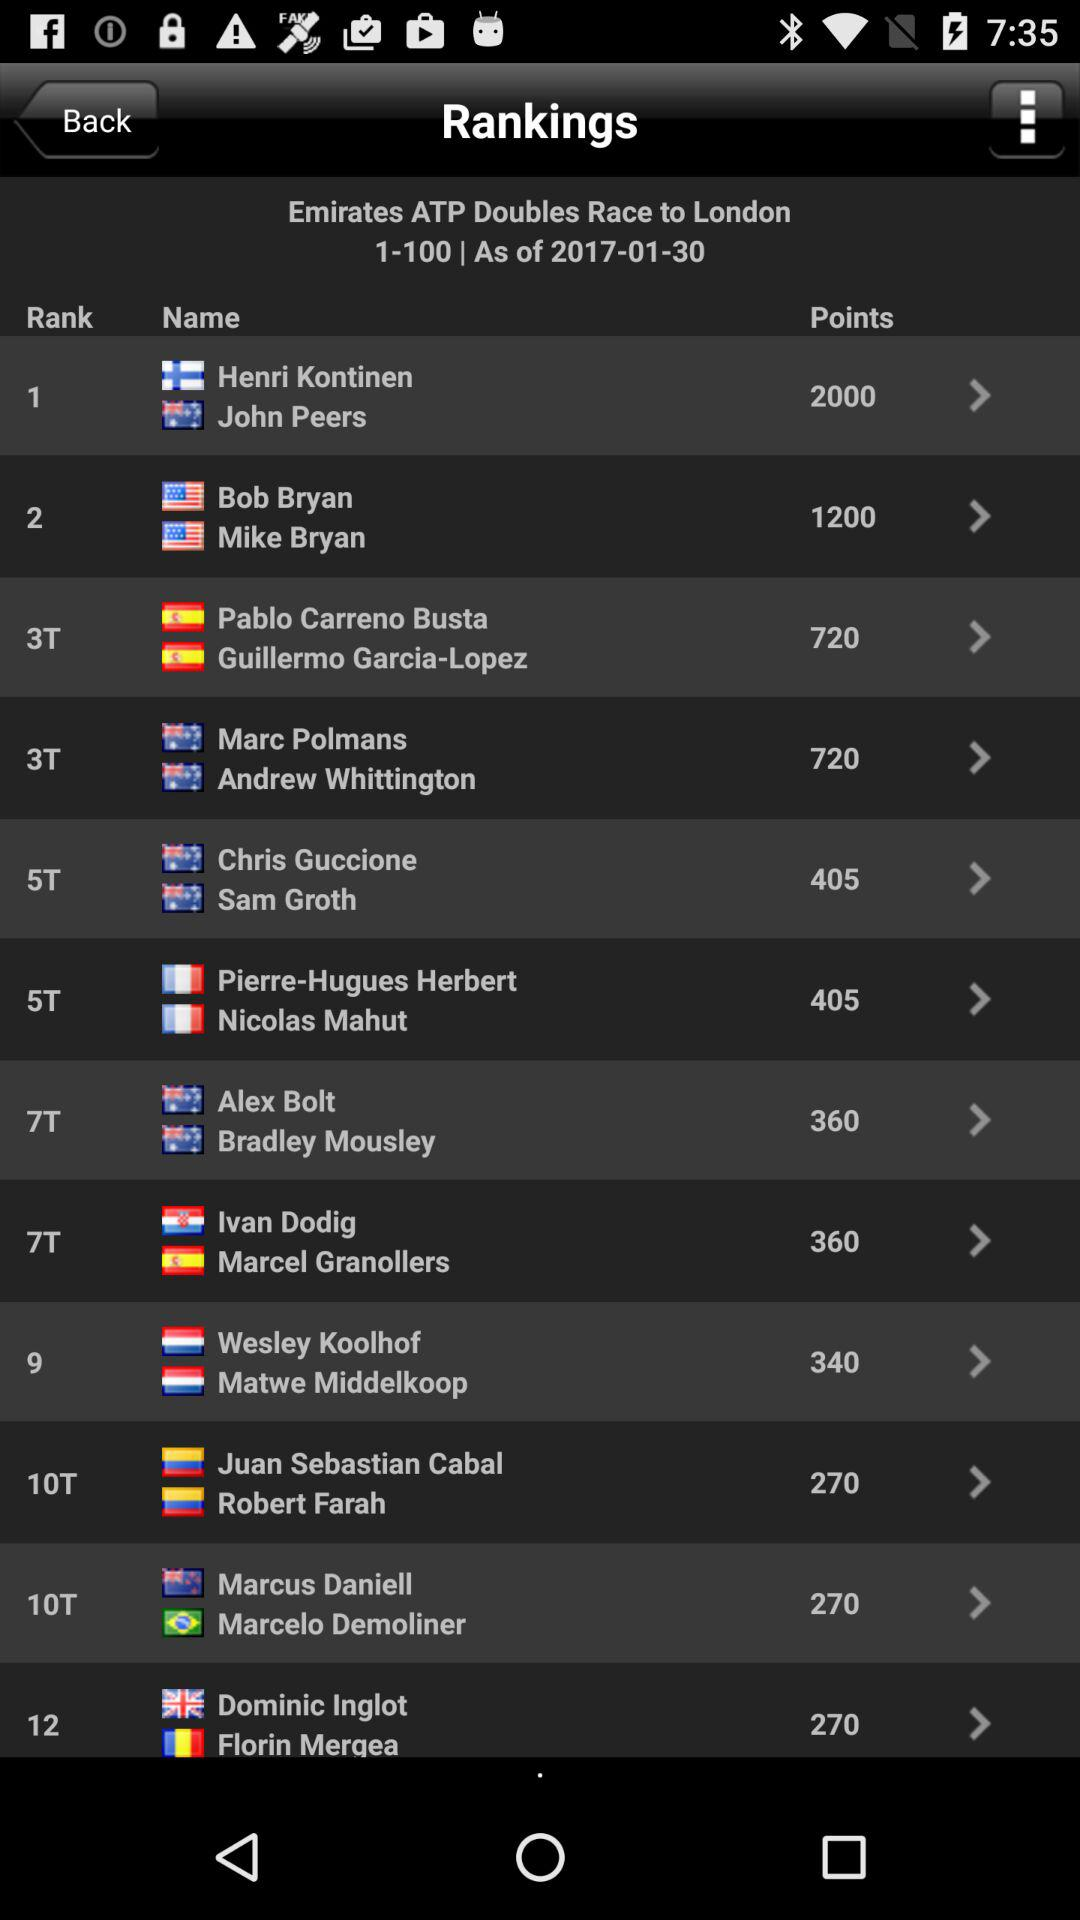How many points does the player in 10th place have?
Answer the question using a single word or phrase. 270 